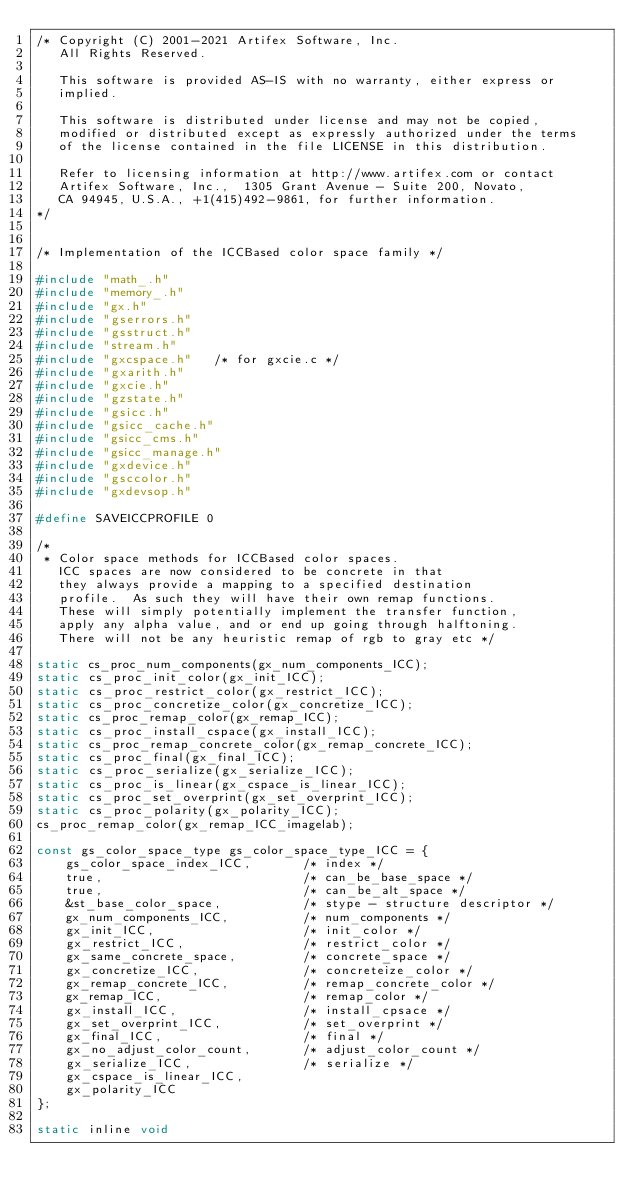Convert code to text. <code><loc_0><loc_0><loc_500><loc_500><_C_>/* Copyright (C) 2001-2021 Artifex Software, Inc.
   All Rights Reserved.

   This software is provided AS-IS with no warranty, either express or
   implied.

   This software is distributed under license and may not be copied,
   modified or distributed except as expressly authorized under the terms
   of the license contained in the file LICENSE in this distribution.

   Refer to licensing information at http://www.artifex.com or contact
   Artifex Software, Inc.,  1305 Grant Avenue - Suite 200, Novato,
   CA 94945, U.S.A., +1(415)492-9861, for further information.
*/


/* Implementation of the ICCBased color space family */

#include "math_.h"
#include "memory_.h"
#include "gx.h"
#include "gserrors.h"
#include "gsstruct.h"
#include "stream.h"
#include "gxcspace.h"		/* for gxcie.c */
#include "gxarith.h"
#include "gxcie.h"
#include "gzstate.h"
#include "gsicc.h"
#include "gsicc_cache.h"
#include "gsicc_cms.h"
#include "gsicc_manage.h"
#include "gxdevice.h"
#include "gsccolor.h"
#include "gxdevsop.h"

#define SAVEICCPROFILE 0

/*
 * Color space methods for ICCBased color spaces.
   ICC spaces are now considered to be concrete in that
   they always provide a mapping to a specified destination
   profile.  As such they will have their own remap functions.
   These will simply potentially implement the transfer function,
   apply any alpha value, and or end up going through halftoning.
   There will not be any heuristic remap of rgb to gray etc */

static cs_proc_num_components(gx_num_components_ICC);
static cs_proc_init_color(gx_init_ICC);
static cs_proc_restrict_color(gx_restrict_ICC);
static cs_proc_concretize_color(gx_concretize_ICC);
static cs_proc_remap_color(gx_remap_ICC);
static cs_proc_install_cspace(gx_install_ICC);
static cs_proc_remap_concrete_color(gx_remap_concrete_ICC);
static cs_proc_final(gx_final_ICC);
static cs_proc_serialize(gx_serialize_ICC);
static cs_proc_is_linear(gx_cspace_is_linear_ICC);
static cs_proc_set_overprint(gx_set_overprint_ICC);
static cs_proc_polarity(gx_polarity_ICC);
cs_proc_remap_color(gx_remap_ICC_imagelab);

const gs_color_space_type gs_color_space_type_ICC = {
    gs_color_space_index_ICC,       /* index */
    true,                           /* can_be_base_space */
    true,                           /* can_be_alt_space */
    &st_base_color_space,           /* stype - structure descriptor */
    gx_num_components_ICC,          /* num_components */
    gx_init_ICC,                    /* init_color */
    gx_restrict_ICC,                /* restrict_color */
    gx_same_concrete_space,         /* concrete_space */
    gx_concretize_ICC,              /* concreteize_color */
    gx_remap_concrete_ICC,          /* remap_concrete_color */
    gx_remap_ICC,                   /* remap_color */
    gx_install_ICC,                 /* install_cpsace */
    gx_set_overprint_ICC,           /* set_overprint */
    gx_final_ICC,                   /* final */
    gx_no_adjust_color_count,       /* adjust_color_count */
    gx_serialize_ICC,               /* serialize */
    gx_cspace_is_linear_ICC,
    gx_polarity_ICC
};

static inline void</code> 